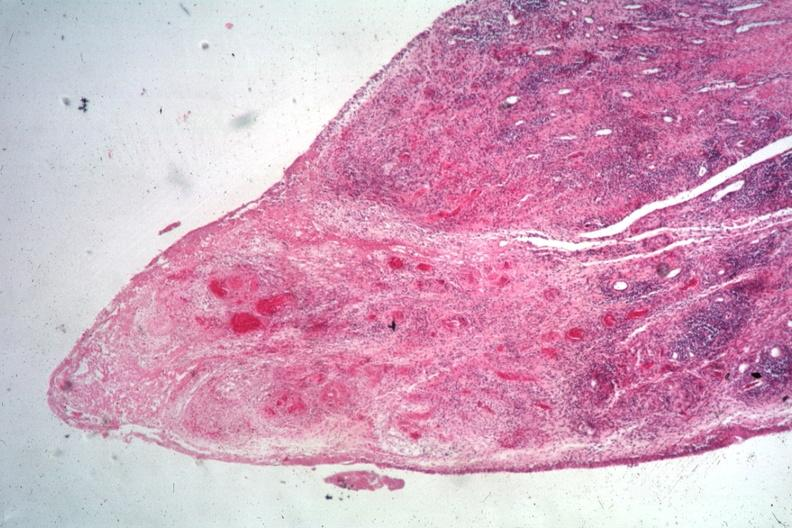s joints present?
Answer the question using a single word or phrase. Yes 